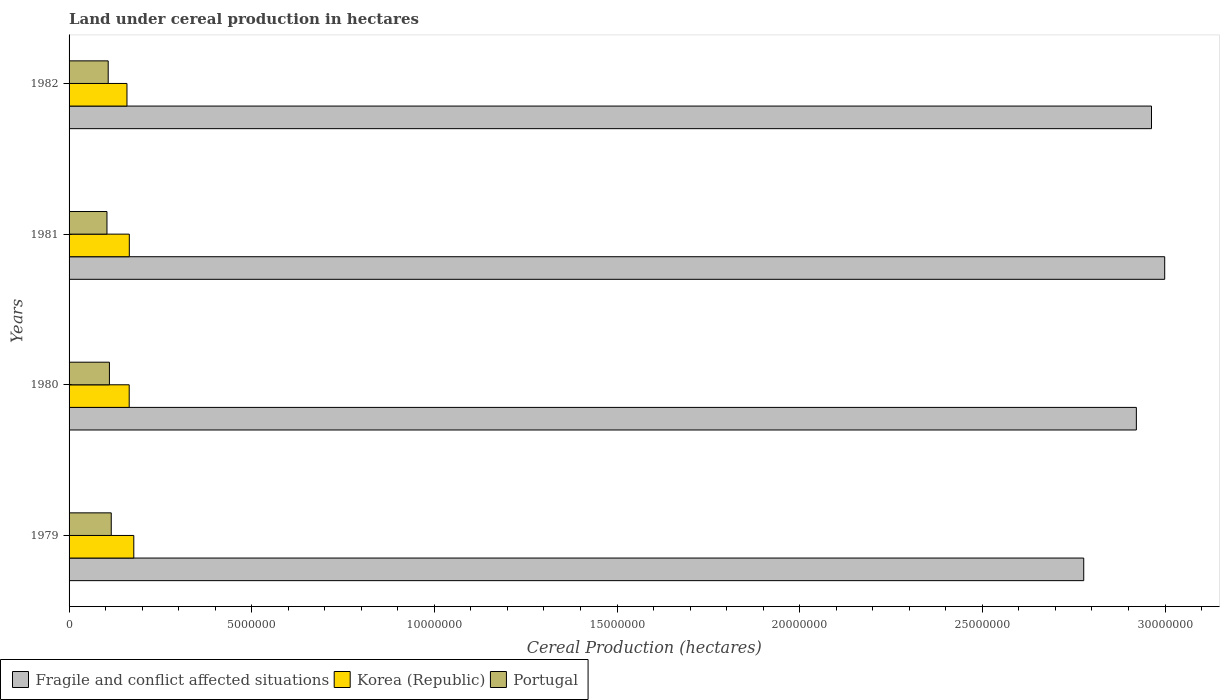How many groups of bars are there?
Provide a short and direct response. 4. How many bars are there on the 3rd tick from the top?
Your response must be concise. 3. What is the label of the 4th group of bars from the top?
Your answer should be compact. 1979. What is the land under cereal production in Fragile and conflict affected situations in 1981?
Ensure brevity in your answer.  3.00e+07. Across all years, what is the maximum land under cereal production in Fragile and conflict affected situations?
Offer a very short reply. 3.00e+07. Across all years, what is the minimum land under cereal production in Fragile and conflict affected situations?
Offer a terse response. 2.78e+07. In which year was the land under cereal production in Fragile and conflict affected situations minimum?
Make the answer very short. 1979. What is the total land under cereal production in Fragile and conflict affected situations in the graph?
Make the answer very short. 1.17e+08. What is the difference between the land under cereal production in Portugal in 1979 and that in 1981?
Offer a terse response. 1.17e+05. What is the difference between the land under cereal production in Portugal in 1981 and the land under cereal production in Korea (Republic) in 1979?
Your answer should be very brief. -7.35e+05. What is the average land under cereal production in Korea (Republic) per year?
Make the answer very short. 1.66e+06. In the year 1982, what is the difference between the land under cereal production in Fragile and conflict affected situations and land under cereal production in Korea (Republic)?
Your answer should be very brief. 2.80e+07. What is the ratio of the land under cereal production in Korea (Republic) in 1979 to that in 1980?
Provide a succinct answer. 1.08. Is the difference between the land under cereal production in Fragile and conflict affected situations in 1979 and 1982 greater than the difference between the land under cereal production in Korea (Republic) in 1979 and 1982?
Your answer should be very brief. No. What is the difference between the highest and the second highest land under cereal production in Portugal?
Provide a short and direct response. 5.01e+04. What is the difference between the highest and the lowest land under cereal production in Portugal?
Offer a very short reply. 1.17e+05. Is the sum of the land under cereal production in Portugal in 1979 and 1980 greater than the maximum land under cereal production in Fragile and conflict affected situations across all years?
Provide a short and direct response. No. What does the 1st bar from the top in 1979 represents?
Your answer should be very brief. Portugal. What does the 2nd bar from the bottom in 1982 represents?
Ensure brevity in your answer.  Korea (Republic). How many bars are there?
Offer a terse response. 12. Are all the bars in the graph horizontal?
Offer a very short reply. Yes. Does the graph contain any zero values?
Your answer should be compact. No. Does the graph contain grids?
Offer a terse response. No. How many legend labels are there?
Ensure brevity in your answer.  3. What is the title of the graph?
Give a very brief answer. Land under cereal production in hectares. Does "Nicaragua" appear as one of the legend labels in the graph?
Provide a succinct answer. No. What is the label or title of the X-axis?
Offer a very short reply. Cereal Production (hectares). What is the Cereal Production (hectares) of Fragile and conflict affected situations in 1979?
Your answer should be compact. 2.78e+07. What is the Cereal Production (hectares) of Korea (Republic) in 1979?
Give a very brief answer. 1.77e+06. What is the Cereal Production (hectares) of Portugal in 1979?
Keep it short and to the point. 1.15e+06. What is the Cereal Production (hectares) of Fragile and conflict affected situations in 1980?
Your response must be concise. 2.92e+07. What is the Cereal Production (hectares) of Korea (Republic) in 1980?
Provide a succinct answer. 1.65e+06. What is the Cereal Production (hectares) in Portugal in 1980?
Keep it short and to the point. 1.10e+06. What is the Cereal Production (hectares) in Fragile and conflict affected situations in 1981?
Offer a terse response. 3.00e+07. What is the Cereal Production (hectares) of Korea (Republic) in 1981?
Make the answer very short. 1.65e+06. What is the Cereal Production (hectares) of Portugal in 1981?
Your answer should be very brief. 1.04e+06. What is the Cereal Production (hectares) in Fragile and conflict affected situations in 1982?
Keep it short and to the point. 2.96e+07. What is the Cereal Production (hectares) in Korea (Republic) in 1982?
Your response must be concise. 1.58e+06. What is the Cereal Production (hectares) in Portugal in 1982?
Give a very brief answer. 1.07e+06. Across all years, what is the maximum Cereal Production (hectares) of Fragile and conflict affected situations?
Give a very brief answer. 3.00e+07. Across all years, what is the maximum Cereal Production (hectares) of Korea (Republic)?
Give a very brief answer. 1.77e+06. Across all years, what is the maximum Cereal Production (hectares) of Portugal?
Your answer should be very brief. 1.15e+06. Across all years, what is the minimum Cereal Production (hectares) of Fragile and conflict affected situations?
Offer a terse response. 2.78e+07. Across all years, what is the minimum Cereal Production (hectares) of Korea (Republic)?
Ensure brevity in your answer.  1.58e+06. Across all years, what is the minimum Cereal Production (hectares) in Portugal?
Provide a short and direct response. 1.04e+06. What is the total Cereal Production (hectares) in Fragile and conflict affected situations in the graph?
Offer a terse response. 1.17e+08. What is the total Cereal Production (hectares) of Korea (Republic) in the graph?
Offer a very short reply. 6.65e+06. What is the total Cereal Production (hectares) of Portugal in the graph?
Your response must be concise. 4.37e+06. What is the difference between the Cereal Production (hectares) in Fragile and conflict affected situations in 1979 and that in 1980?
Make the answer very short. -1.44e+06. What is the difference between the Cereal Production (hectares) in Korea (Republic) in 1979 and that in 1980?
Your response must be concise. 1.26e+05. What is the difference between the Cereal Production (hectares) of Portugal in 1979 and that in 1980?
Your answer should be very brief. 5.01e+04. What is the difference between the Cereal Production (hectares) in Fragile and conflict affected situations in 1979 and that in 1981?
Your answer should be compact. -2.22e+06. What is the difference between the Cereal Production (hectares) in Korea (Republic) in 1979 and that in 1981?
Provide a succinct answer. 1.23e+05. What is the difference between the Cereal Production (hectares) of Portugal in 1979 and that in 1981?
Your answer should be compact. 1.17e+05. What is the difference between the Cereal Production (hectares) in Fragile and conflict affected situations in 1979 and that in 1982?
Offer a terse response. -1.86e+06. What is the difference between the Cereal Production (hectares) in Korea (Republic) in 1979 and that in 1982?
Give a very brief answer. 1.87e+05. What is the difference between the Cereal Production (hectares) of Portugal in 1979 and that in 1982?
Give a very brief answer. 8.33e+04. What is the difference between the Cereal Production (hectares) in Fragile and conflict affected situations in 1980 and that in 1981?
Make the answer very short. -7.76e+05. What is the difference between the Cereal Production (hectares) of Korea (Republic) in 1980 and that in 1981?
Offer a terse response. -2707. What is the difference between the Cereal Production (hectares) in Portugal in 1980 and that in 1981?
Ensure brevity in your answer.  6.71e+04. What is the difference between the Cereal Production (hectares) of Fragile and conflict affected situations in 1980 and that in 1982?
Give a very brief answer. -4.15e+05. What is the difference between the Cereal Production (hectares) of Korea (Republic) in 1980 and that in 1982?
Give a very brief answer. 6.15e+04. What is the difference between the Cereal Production (hectares) in Portugal in 1980 and that in 1982?
Make the answer very short. 3.32e+04. What is the difference between the Cereal Production (hectares) in Fragile and conflict affected situations in 1981 and that in 1982?
Provide a succinct answer. 3.61e+05. What is the difference between the Cereal Production (hectares) of Korea (Republic) in 1981 and that in 1982?
Provide a short and direct response. 6.42e+04. What is the difference between the Cereal Production (hectares) of Portugal in 1981 and that in 1982?
Offer a terse response. -3.39e+04. What is the difference between the Cereal Production (hectares) in Fragile and conflict affected situations in 1979 and the Cereal Production (hectares) in Korea (Republic) in 1980?
Keep it short and to the point. 2.61e+07. What is the difference between the Cereal Production (hectares) in Fragile and conflict affected situations in 1979 and the Cereal Production (hectares) in Portugal in 1980?
Provide a succinct answer. 2.67e+07. What is the difference between the Cereal Production (hectares) of Korea (Republic) in 1979 and the Cereal Production (hectares) of Portugal in 1980?
Your answer should be compact. 6.67e+05. What is the difference between the Cereal Production (hectares) of Fragile and conflict affected situations in 1979 and the Cereal Production (hectares) of Korea (Republic) in 1981?
Your answer should be very brief. 2.61e+07. What is the difference between the Cereal Production (hectares) of Fragile and conflict affected situations in 1979 and the Cereal Production (hectares) of Portugal in 1981?
Provide a succinct answer. 2.67e+07. What is the difference between the Cereal Production (hectares) of Korea (Republic) in 1979 and the Cereal Production (hectares) of Portugal in 1981?
Ensure brevity in your answer.  7.35e+05. What is the difference between the Cereal Production (hectares) in Fragile and conflict affected situations in 1979 and the Cereal Production (hectares) in Korea (Republic) in 1982?
Offer a terse response. 2.62e+07. What is the difference between the Cereal Production (hectares) in Fragile and conflict affected situations in 1979 and the Cereal Production (hectares) in Portugal in 1982?
Provide a succinct answer. 2.67e+07. What is the difference between the Cereal Production (hectares) in Korea (Republic) in 1979 and the Cereal Production (hectares) in Portugal in 1982?
Make the answer very short. 7.01e+05. What is the difference between the Cereal Production (hectares) in Fragile and conflict affected situations in 1980 and the Cereal Production (hectares) in Korea (Republic) in 1981?
Provide a short and direct response. 2.76e+07. What is the difference between the Cereal Production (hectares) of Fragile and conflict affected situations in 1980 and the Cereal Production (hectares) of Portugal in 1981?
Keep it short and to the point. 2.82e+07. What is the difference between the Cereal Production (hectares) of Korea (Republic) in 1980 and the Cereal Production (hectares) of Portugal in 1981?
Make the answer very short. 6.09e+05. What is the difference between the Cereal Production (hectares) of Fragile and conflict affected situations in 1980 and the Cereal Production (hectares) of Korea (Republic) in 1982?
Offer a very short reply. 2.76e+07. What is the difference between the Cereal Production (hectares) in Fragile and conflict affected situations in 1980 and the Cereal Production (hectares) in Portugal in 1982?
Your answer should be compact. 2.81e+07. What is the difference between the Cereal Production (hectares) in Korea (Republic) in 1980 and the Cereal Production (hectares) in Portugal in 1982?
Provide a short and direct response. 5.75e+05. What is the difference between the Cereal Production (hectares) in Fragile and conflict affected situations in 1981 and the Cereal Production (hectares) in Korea (Republic) in 1982?
Ensure brevity in your answer.  2.84e+07. What is the difference between the Cereal Production (hectares) of Fragile and conflict affected situations in 1981 and the Cereal Production (hectares) of Portugal in 1982?
Your response must be concise. 2.89e+07. What is the difference between the Cereal Production (hectares) in Korea (Republic) in 1981 and the Cereal Production (hectares) in Portugal in 1982?
Provide a succinct answer. 5.78e+05. What is the average Cereal Production (hectares) of Fragile and conflict affected situations per year?
Keep it short and to the point. 2.92e+07. What is the average Cereal Production (hectares) of Korea (Republic) per year?
Offer a terse response. 1.66e+06. What is the average Cereal Production (hectares) of Portugal per year?
Your answer should be very brief. 1.09e+06. In the year 1979, what is the difference between the Cereal Production (hectares) of Fragile and conflict affected situations and Cereal Production (hectares) of Korea (Republic)?
Offer a terse response. 2.60e+07. In the year 1979, what is the difference between the Cereal Production (hectares) of Fragile and conflict affected situations and Cereal Production (hectares) of Portugal?
Provide a succinct answer. 2.66e+07. In the year 1979, what is the difference between the Cereal Production (hectares) of Korea (Republic) and Cereal Production (hectares) of Portugal?
Your response must be concise. 6.17e+05. In the year 1980, what is the difference between the Cereal Production (hectares) of Fragile and conflict affected situations and Cereal Production (hectares) of Korea (Republic)?
Give a very brief answer. 2.76e+07. In the year 1980, what is the difference between the Cereal Production (hectares) in Fragile and conflict affected situations and Cereal Production (hectares) in Portugal?
Keep it short and to the point. 2.81e+07. In the year 1980, what is the difference between the Cereal Production (hectares) in Korea (Republic) and Cereal Production (hectares) in Portugal?
Your answer should be compact. 5.42e+05. In the year 1981, what is the difference between the Cereal Production (hectares) of Fragile and conflict affected situations and Cereal Production (hectares) of Korea (Republic)?
Ensure brevity in your answer.  2.83e+07. In the year 1981, what is the difference between the Cereal Production (hectares) of Fragile and conflict affected situations and Cereal Production (hectares) of Portugal?
Provide a short and direct response. 2.90e+07. In the year 1981, what is the difference between the Cereal Production (hectares) in Korea (Republic) and Cereal Production (hectares) in Portugal?
Give a very brief answer. 6.12e+05. In the year 1982, what is the difference between the Cereal Production (hectares) of Fragile and conflict affected situations and Cereal Production (hectares) of Korea (Republic)?
Make the answer very short. 2.80e+07. In the year 1982, what is the difference between the Cereal Production (hectares) of Fragile and conflict affected situations and Cereal Production (hectares) of Portugal?
Make the answer very short. 2.86e+07. In the year 1982, what is the difference between the Cereal Production (hectares) of Korea (Republic) and Cereal Production (hectares) of Portugal?
Provide a short and direct response. 5.14e+05. What is the ratio of the Cereal Production (hectares) of Fragile and conflict affected situations in 1979 to that in 1980?
Your answer should be compact. 0.95. What is the ratio of the Cereal Production (hectares) in Korea (Republic) in 1979 to that in 1980?
Provide a succinct answer. 1.08. What is the ratio of the Cereal Production (hectares) of Portugal in 1979 to that in 1980?
Ensure brevity in your answer.  1.05. What is the ratio of the Cereal Production (hectares) in Fragile and conflict affected situations in 1979 to that in 1981?
Your answer should be very brief. 0.93. What is the ratio of the Cereal Production (hectares) of Korea (Republic) in 1979 to that in 1981?
Your answer should be compact. 1.07. What is the ratio of the Cereal Production (hectares) of Portugal in 1979 to that in 1981?
Your response must be concise. 1.11. What is the ratio of the Cereal Production (hectares) of Fragile and conflict affected situations in 1979 to that in 1982?
Offer a very short reply. 0.94. What is the ratio of the Cereal Production (hectares) in Korea (Republic) in 1979 to that in 1982?
Your answer should be compact. 1.12. What is the ratio of the Cereal Production (hectares) in Portugal in 1979 to that in 1982?
Make the answer very short. 1.08. What is the ratio of the Cereal Production (hectares) of Fragile and conflict affected situations in 1980 to that in 1981?
Keep it short and to the point. 0.97. What is the ratio of the Cereal Production (hectares) of Portugal in 1980 to that in 1981?
Ensure brevity in your answer.  1.06. What is the ratio of the Cereal Production (hectares) in Korea (Republic) in 1980 to that in 1982?
Your response must be concise. 1.04. What is the ratio of the Cereal Production (hectares) in Portugal in 1980 to that in 1982?
Make the answer very short. 1.03. What is the ratio of the Cereal Production (hectares) in Fragile and conflict affected situations in 1981 to that in 1982?
Your response must be concise. 1.01. What is the ratio of the Cereal Production (hectares) of Korea (Republic) in 1981 to that in 1982?
Provide a succinct answer. 1.04. What is the ratio of the Cereal Production (hectares) of Portugal in 1981 to that in 1982?
Keep it short and to the point. 0.97. What is the difference between the highest and the second highest Cereal Production (hectares) of Fragile and conflict affected situations?
Provide a succinct answer. 3.61e+05. What is the difference between the highest and the second highest Cereal Production (hectares) of Korea (Republic)?
Ensure brevity in your answer.  1.23e+05. What is the difference between the highest and the second highest Cereal Production (hectares) in Portugal?
Make the answer very short. 5.01e+04. What is the difference between the highest and the lowest Cereal Production (hectares) of Fragile and conflict affected situations?
Keep it short and to the point. 2.22e+06. What is the difference between the highest and the lowest Cereal Production (hectares) in Korea (Republic)?
Provide a short and direct response. 1.87e+05. What is the difference between the highest and the lowest Cereal Production (hectares) of Portugal?
Provide a short and direct response. 1.17e+05. 